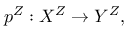Convert formula to latex. <formula><loc_0><loc_0><loc_500><loc_500>p ^ { Z } \colon X ^ { Z } \to Y ^ { Z } ,</formula> 